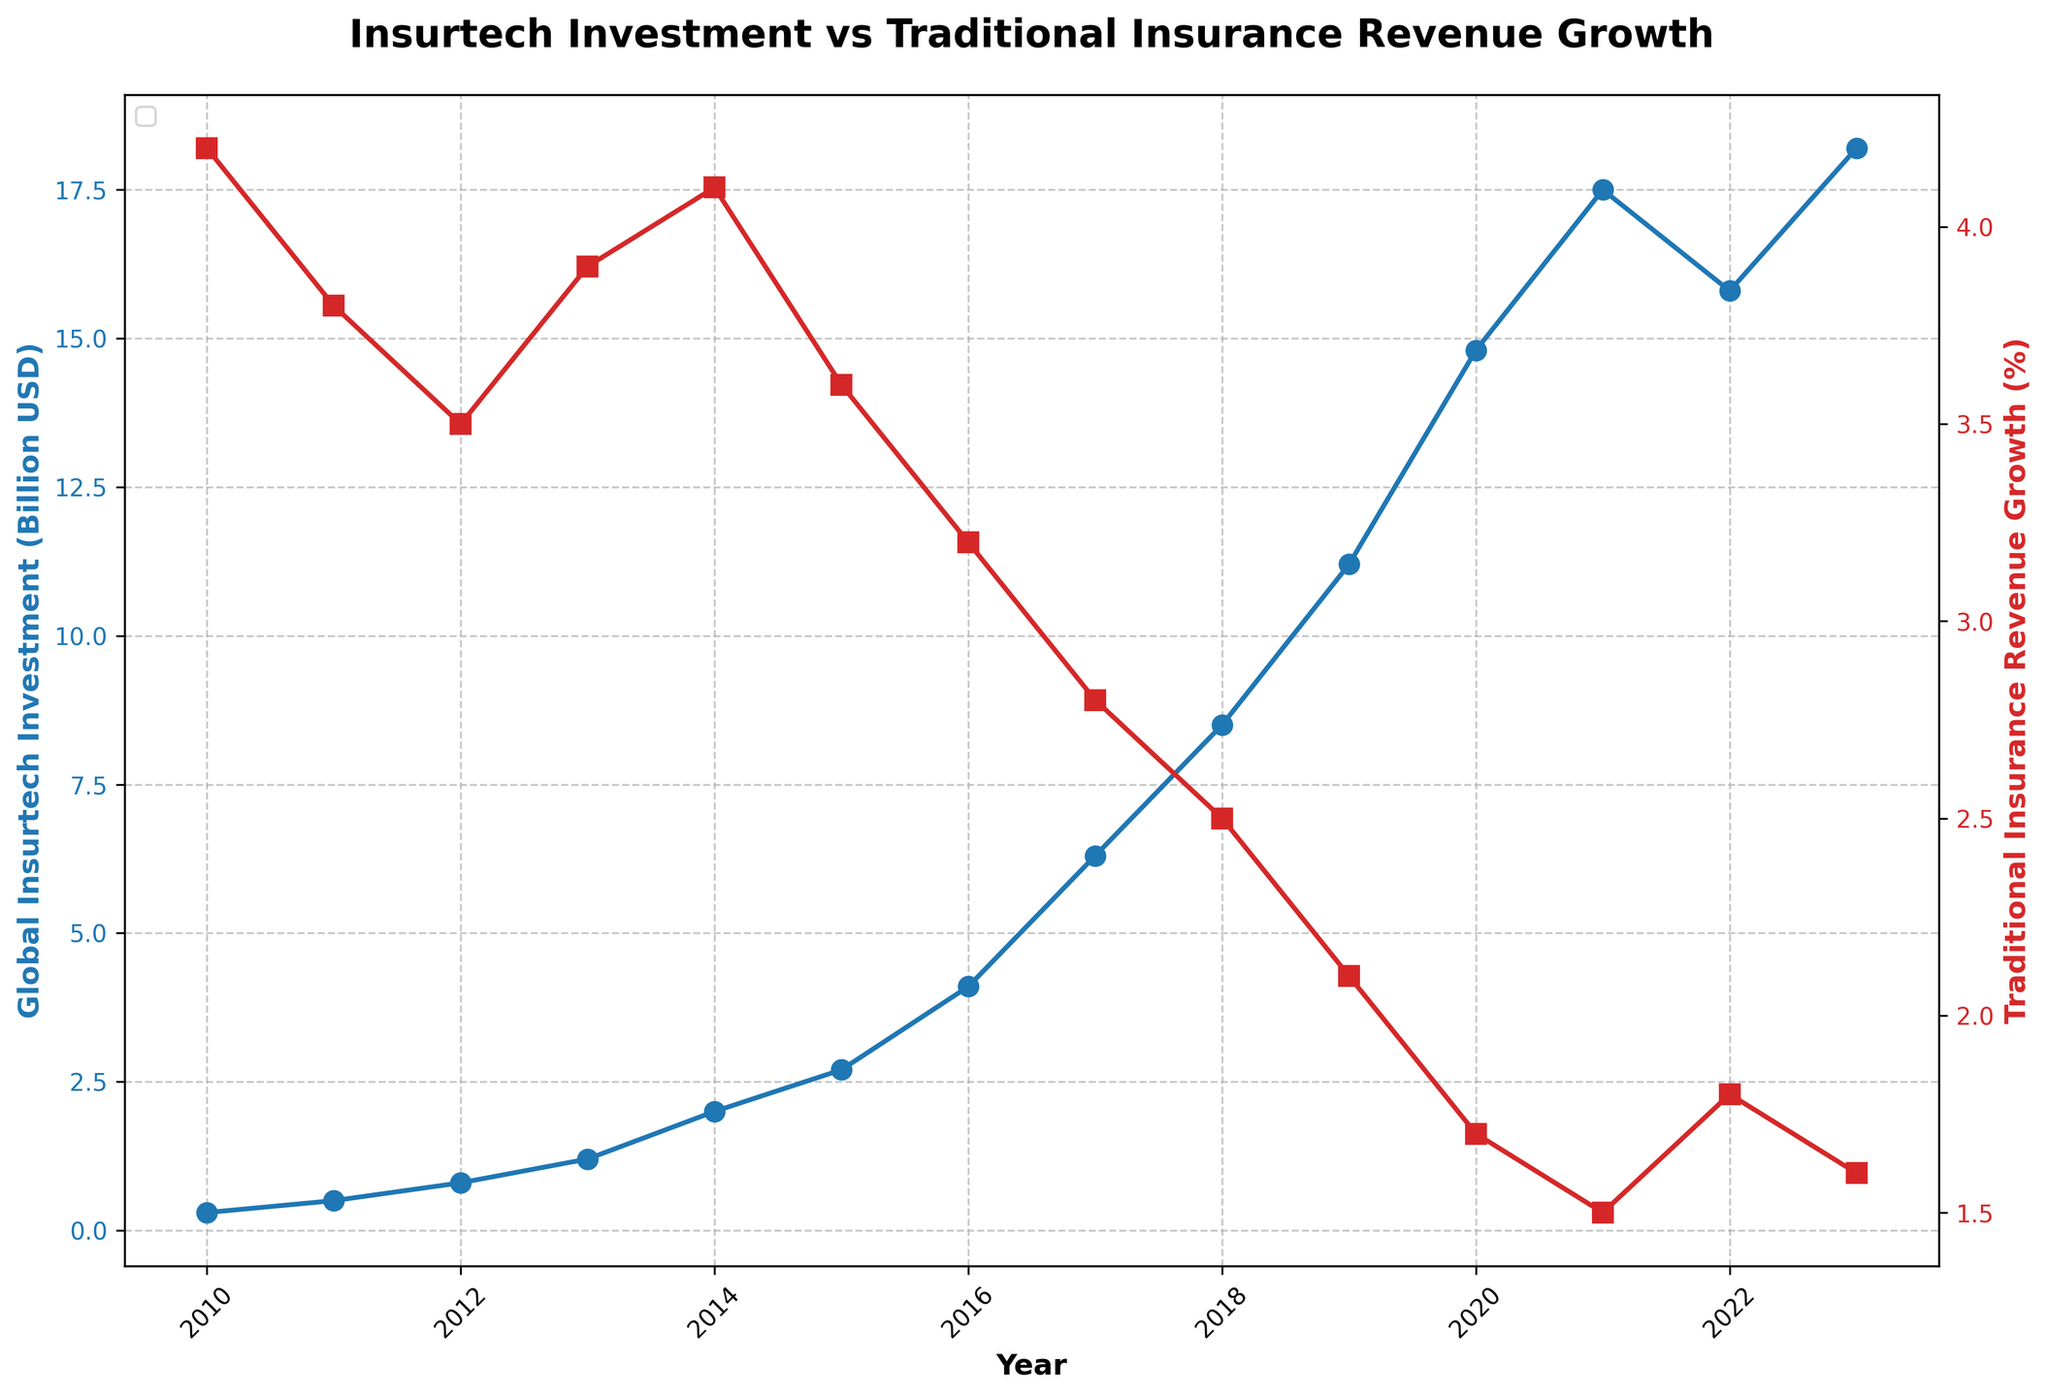What is the trend for Global Insurtech Investment from 2010 to 2023? The Global Insurtech Investment has shown an upward trend, starting from 0.3 billion USD in 2010 and reaching 18.2 billion USD in 2023.
Answer: Upward trend How has Traditional Insurance Revenue Growth changed over the same period? The Traditional Insurance Revenue Growth has shown a downward trend, decreasing from 4.2% in 2010 to around 1.6% in 2023.
Answer: Downward trend What year saw the highest Global Insurtech Investment, and what was the investment amount? The year 2023 saw the highest Global Insurtech Investment amounting to 18.2 billion USD.
Answer: 2023, 18.2 billion USD Compare the Traditional Insurance Revenue Growth in 2010 to that in 2023. Which year had a higher growth rate? In 2010, the Traditional Insurance Revenue Growth was 4.2%, while in 2023 it was 1.6%. Therefore, 2010 had a higher growth rate.
Answer: 2010 By how much did Global Insurtech Investment increase from 2010 to 2023? The Global Insurtech Investment increased from 0.3 billion USD in 2010 to 18.2 billion USD in 2023. The increase can be calculated as 18.2 - 0.3 = 17.9 billion USD.
Answer: 17.9 billion USD Which visual attribute is used to represent Traditional Insurance Revenue Growth in the figure? The Traditional Insurance Revenue Growth is represented using a red line with square markers.
Answer: Red line with square markers What is the overall relationship between Global Insurtech Investment and Traditional Insurance Revenue Growth over the period? There is an inverse relationship between the two; as Global Insurtech Investment increased, Traditional Insurance Revenue Growth decreased.
Answer: Inverse relationship What is the average Global Insurtech Investment from 2010 to 2023? To find the average, sum up the investment amounts from each year and divide by the number of years: (0.3 + 0.5 + 0.8 + 1.2 + 2.0 + 2.7 + 4.1 + 6.3 + 8.5 + 11.2 + 14.8 + 17.5 + 15.8 + 18.2) / 14 = 7.925 billion USD.
Answer: 7.925 billion USD Which year had the lowest Traditional Insurance Revenue Growth, and what was the rate? The year 2021 had the lowest Traditional Insurance Revenue Growth at 1.5%.
Answer: 2021, 1.5% How did the investment in Insurtech change between 2019 and 2020? Between 2019 and 2020, the Global Insurtech Investment increased from 11.2 billion USD to 14.8 billion USD. The change can be calculated as 14.8 - 11.2 = 3.6 billion USD.
Answer: 3.6 billion USD 